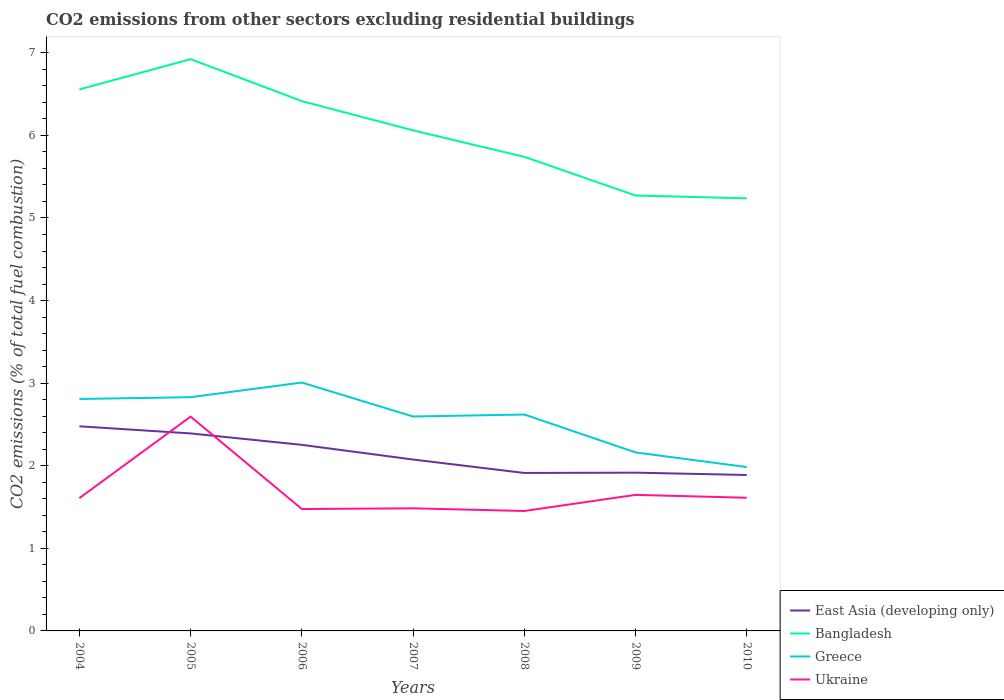Does the line corresponding to Greece intersect with the line corresponding to Bangladesh?
Offer a terse response. No. Is the number of lines equal to the number of legend labels?
Make the answer very short. Yes. Across all years, what is the maximum total CO2 emitted in Greece?
Make the answer very short. 1.98. In which year was the total CO2 emitted in East Asia (developing only) maximum?
Your response must be concise. 2010. What is the total total CO2 emitted in Greece in the graph?
Your response must be concise. 0.21. What is the difference between the highest and the second highest total CO2 emitted in Ukraine?
Keep it short and to the point. 1.14. What is the difference between the highest and the lowest total CO2 emitted in East Asia (developing only)?
Provide a short and direct response. 3. Is the total CO2 emitted in Bangladesh strictly greater than the total CO2 emitted in Ukraine over the years?
Ensure brevity in your answer.  No. How many years are there in the graph?
Ensure brevity in your answer.  7. Are the values on the major ticks of Y-axis written in scientific E-notation?
Offer a very short reply. No. Where does the legend appear in the graph?
Provide a succinct answer. Bottom right. How many legend labels are there?
Ensure brevity in your answer.  4. What is the title of the graph?
Keep it short and to the point. CO2 emissions from other sectors excluding residential buildings. What is the label or title of the X-axis?
Make the answer very short. Years. What is the label or title of the Y-axis?
Offer a very short reply. CO2 emissions (% of total fuel combustion). What is the CO2 emissions (% of total fuel combustion) in East Asia (developing only) in 2004?
Offer a terse response. 2.48. What is the CO2 emissions (% of total fuel combustion) in Bangladesh in 2004?
Give a very brief answer. 6.56. What is the CO2 emissions (% of total fuel combustion) of Greece in 2004?
Keep it short and to the point. 2.81. What is the CO2 emissions (% of total fuel combustion) of Ukraine in 2004?
Your response must be concise. 1.61. What is the CO2 emissions (% of total fuel combustion) in East Asia (developing only) in 2005?
Give a very brief answer. 2.39. What is the CO2 emissions (% of total fuel combustion) of Bangladesh in 2005?
Give a very brief answer. 6.92. What is the CO2 emissions (% of total fuel combustion) in Greece in 2005?
Offer a terse response. 2.83. What is the CO2 emissions (% of total fuel combustion) of Ukraine in 2005?
Offer a very short reply. 2.59. What is the CO2 emissions (% of total fuel combustion) in East Asia (developing only) in 2006?
Offer a terse response. 2.25. What is the CO2 emissions (% of total fuel combustion) in Bangladesh in 2006?
Your answer should be compact. 6.42. What is the CO2 emissions (% of total fuel combustion) in Greece in 2006?
Give a very brief answer. 3.01. What is the CO2 emissions (% of total fuel combustion) of Ukraine in 2006?
Your answer should be very brief. 1.48. What is the CO2 emissions (% of total fuel combustion) in East Asia (developing only) in 2007?
Your answer should be very brief. 2.08. What is the CO2 emissions (% of total fuel combustion) in Bangladesh in 2007?
Your answer should be compact. 6.06. What is the CO2 emissions (% of total fuel combustion) of Greece in 2007?
Your answer should be very brief. 2.6. What is the CO2 emissions (% of total fuel combustion) of Ukraine in 2007?
Make the answer very short. 1.48. What is the CO2 emissions (% of total fuel combustion) of East Asia (developing only) in 2008?
Keep it short and to the point. 1.91. What is the CO2 emissions (% of total fuel combustion) of Bangladesh in 2008?
Ensure brevity in your answer.  5.74. What is the CO2 emissions (% of total fuel combustion) in Greece in 2008?
Offer a very short reply. 2.62. What is the CO2 emissions (% of total fuel combustion) in Ukraine in 2008?
Your response must be concise. 1.45. What is the CO2 emissions (% of total fuel combustion) of East Asia (developing only) in 2009?
Give a very brief answer. 1.92. What is the CO2 emissions (% of total fuel combustion) of Bangladesh in 2009?
Your answer should be compact. 5.27. What is the CO2 emissions (% of total fuel combustion) in Greece in 2009?
Offer a terse response. 2.16. What is the CO2 emissions (% of total fuel combustion) in Ukraine in 2009?
Give a very brief answer. 1.65. What is the CO2 emissions (% of total fuel combustion) of East Asia (developing only) in 2010?
Offer a very short reply. 1.89. What is the CO2 emissions (% of total fuel combustion) in Bangladesh in 2010?
Your response must be concise. 5.24. What is the CO2 emissions (% of total fuel combustion) in Greece in 2010?
Provide a succinct answer. 1.98. What is the CO2 emissions (% of total fuel combustion) of Ukraine in 2010?
Provide a short and direct response. 1.61. Across all years, what is the maximum CO2 emissions (% of total fuel combustion) in East Asia (developing only)?
Offer a very short reply. 2.48. Across all years, what is the maximum CO2 emissions (% of total fuel combustion) in Bangladesh?
Keep it short and to the point. 6.92. Across all years, what is the maximum CO2 emissions (% of total fuel combustion) in Greece?
Your answer should be very brief. 3.01. Across all years, what is the maximum CO2 emissions (% of total fuel combustion) of Ukraine?
Give a very brief answer. 2.59. Across all years, what is the minimum CO2 emissions (% of total fuel combustion) of East Asia (developing only)?
Offer a very short reply. 1.89. Across all years, what is the minimum CO2 emissions (% of total fuel combustion) in Bangladesh?
Provide a short and direct response. 5.24. Across all years, what is the minimum CO2 emissions (% of total fuel combustion) in Greece?
Offer a very short reply. 1.98. Across all years, what is the minimum CO2 emissions (% of total fuel combustion) of Ukraine?
Offer a very short reply. 1.45. What is the total CO2 emissions (% of total fuel combustion) of East Asia (developing only) in the graph?
Ensure brevity in your answer.  14.91. What is the total CO2 emissions (% of total fuel combustion) of Bangladesh in the graph?
Provide a succinct answer. 42.21. What is the total CO2 emissions (% of total fuel combustion) in Greece in the graph?
Your answer should be very brief. 18.01. What is the total CO2 emissions (% of total fuel combustion) of Ukraine in the graph?
Provide a short and direct response. 11.88. What is the difference between the CO2 emissions (% of total fuel combustion) of East Asia (developing only) in 2004 and that in 2005?
Provide a short and direct response. 0.09. What is the difference between the CO2 emissions (% of total fuel combustion) of Bangladesh in 2004 and that in 2005?
Provide a succinct answer. -0.37. What is the difference between the CO2 emissions (% of total fuel combustion) of Greece in 2004 and that in 2005?
Offer a very short reply. -0.02. What is the difference between the CO2 emissions (% of total fuel combustion) of Ukraine in 2004 and that in 2005?
Keep it short and to the point. -0.99. What is the difference between the CO2 emissions (% of total fuel combustion) in East Asia (developing only) in 2004 and that in 2006?
Offer a terse response. 0.22. What is the difference between the CO2 emissions (% of total fuel combustion) of Bangladesh in 2004 and that in 2006?
Offer a terse response. 0.14. What is the difference between the CO2 emissions (% of total fuel combustion) of Greece in 2004 and that in 2006?
Your answer should be compact. -0.2. What is the difference between the CO2 emissions (% of total fuel combustion) in Ukraine in 2004 and that in 2006?
Give a very brief answer. 0.13. What is the difference between the CO2 emissions (% of total fuel combustion) in East Asia (developing only) in 2004 and that in 2007?
Provide a short and direct response. 0.4. What is the difference between the CO2 emissions (% of total fuel combustion) of Bangladesh in 2004 and that in 2007?
Offer a terse response. 0.5. What is the difference between the CO2 emissions (% of total fuel combustion) of Greece in 2004 and that in 2007?
Your answer should be compact. 0.21. What is the difference between the CO2 emissions (% of total fuel combustion) of Ukraine in 2004 and that in 2007?
Keep it short and to the point. 0.12. What is the difference between the CO2 emissions (% of total fuel combustion) of East Asia (developing only) in 2004 and that in 2008?
Offer a very short reply. 0.56. What is the difference between the CO2 emissions (% of total fuel combustion) in Bangladesh in 2004 and that in 2008?
Make the answer very short. 0.82. What is the difference between the CO2 emissions (% of total fuel combustion) in Greece in 2004 and that in 2008?
Offer a very short reply. 0.19. What is the difference between the CO2 emissions (% of total fuel combustion) of Ukraine in 2004 and that in 2008?
Your answer should be very brief. 0.16. What is the difference between the CO2 emissions (% of total fuel combustion) of East Asia (developing only) in 2004 and that in 2009?
Give a very brief answer. 0.56. What is the difference between the CO2 emissions (% of total fuel combustion) in Bangladesh in 2004 and that in 2009?
Your answer should be compact. 1.28. What is the difference between the CO2 emissions (% of total fuel combustion) in Greece in 2004 and that in 2009?
Offer a terse response. 0.65. What is the difference between the CO2 emissions (% of total fuel combustion) of Ukraine in 2004 and that in 2009?
Your answer should be very brief. -0.04. What is the difference between the CO2 emissions (% of total fuel combustion) in East Asia (developing only) in 2004 and that in 2010?
Offer a terse response. 0.59. What is the difference between the CO2 emissions (% of total fuel combustion) of Bangladesh in 2004 and that in 2010?
Your answer should be compact. 1.32. What is the difference between the CO2 emissions (% of total fuel combustion) in Greece in 2004 and that in 2010?
Keep it short and to the point. 0.82. What is the difference between the CO2 emissions (% of total fuel combustion) in Ukraine in 2004 and that in 2010?
Ensure brevity in your answer.  -0. What is the difference between the CO2 emissions (% of total fuel combustion) in East Asia (developing only) in 2005 and that in 2006?
Provide a succinct answer. 0.14. What is the difference between the CO2 emissions (% of total fuel combustion) of Bangladesh in 2005 and that in 2006?
Provide a short and direct response. 0.51. What is the difference between the CO2 emissions (% of total fuel combustion) of Greece in 2005 and that in 2006?
Your answer should be compact. -0.18. What is the difference between the CO2 emissions (% of total fuel combustion) of Ukraine in 2005 and that in 2006?
Your response must be concise. 1.12. What is the difference between the CO2 emissions (% of total fuel combustion) of East Asia (developing only) in 2005 and that in 2007?
Ensure brevity in your answer.  0.32. What is the difference between the CO2 emissions (% of total fuel combustion) in Bangladesh in 2005 and that in 2007?
Provide a succinct answer. 0.86. What is the difference between the CO2 emissions (% of total fuel combustion) in Greece in 2005 and that in 2007?
Offer a very short reply. 0.23. What is the difference between the CO2 emissions (% of total fuel combustion) in Ukraine in 2005 and that in 2007?
Make the answer very short. 1.11. What is the difference between the CO2 emissions (% of total fuel combustion) in East Asia (developing only) in 2005 and that in 2008?
Give a very brief answer. 0.48. What is the difference between the CO2 emissions (% of total fuel combustion) of Bangladesh in 2005 and that in 2008?
Provide a short and direct response. 1.18. What is the difference between the CO2 emissions (% of total fuel combustion) of Greece in 2005 and that in 2008?
Your answer should be compact. 0.21. What is the difference between the CO2 emissions (% of total fuel combustion) of Ukraine in 2005 and that in 2008?
Keep it short and to the point. 1.14. What is the difference between the CO2 emissions (% of total fuel combustion) of East Asia (developing only) in 2005 and that in 2009?
Provide a short and direct response. 0.48. What is the difference between the CO2 emissions (% of total fuel combustion) in Bangladesh in 2005 and that in 2009?
Offer a very short reply. 1.65. What is the difference between the CO2 emissions (% of total fuel combustion) in Greece in 2005 and that in 2009?
Your answer should be very brief. 0.67. What is the difference between the CO2 emissions (% of total fuel combustion) of Ukraine in 2005 and that in 2009?
Keep it short and to the point. 0.95. What is the difference between the CO2 emissions (% of total fuel combustion) of East Asia (developing only) in 2005 and that in 2010?
Give a very brief answer. 0.5. What is the difference between the CO2 emissions (% of total fuel combustion) of Bangladesh in 2005 and that in 2010?
Give a very brief answer. 1.69. What is the difference between the CO2 emissions (% of total fuel combustion) of Greece in 2005 and that in 2010?
Ensure brevity in your answer.  0.85. What is the difference between the CO2 emissions (% of total fuel combustion) in Ukraine in 2005 and that in 2010?
Keep it short and to the point. 0.98. What is the difference between the CO2 emissions (% of total fuel combustion) in East Asia (developing only) in 2006 and that in 2007?
Give a very brief answer. 0.18. What is the difference between the CO2 emissions (% of total fuel combustion) of Bangladesh in 2006 and that in 2007?
Your response must be concise. 0.35. What is the difference between the CO2 emissions (% of total fuel combustion) of Greece in 2006 and that in 2007?
Give a very brief answer. 0.41. What is the difference between the CO2 emissions (% of total fuel combustion) of Ukraine in 2006 and that in 2007?
Offer a terse response. -0.01. What is the difference between the CO2 emissions (% of total fuel combustion) of East Asia (developing only) in 2006 and that in 2008?
Your answer should be compact. 0.34. What is the difference between the CO2 emissions (% of total fuel combustion) in Bangladesh in 2006 and that in 2008?
Offer a very short reply. 0.67. What is the difference between the CO2 emissions (% of total fuel combustion) in Greece in 2006 and that in 2008?
Your response must be concise. 0.39. What is the difference between the CO2 emissions (% of total fuel combustion) of Ukraine in 2006 and that in 2008?
Your response must be concise. 0.02. What is the difference between the CO2 emissions (% of total fuel combustion) in East Asia (developing only) in 2006 and that in 2009?
Make the answer very short. 0.34. What is the difference between the CO2 emissions (% of total fuel combustion) of Bangladesh in 2006 and that in 2009?
Offer a terse response. 1.14. What is the difference between the CO2 emissions (% of total fuel combustion) of Greece in 2006 and that in 2009?
Your answer should be compact. 0.85. What is the difference between the CO2 emissions (% of total fuel combustion) in Ukraine in 2006 and that in 2009?
Offer a very short reply. -0.17. What is the difference between the CO2 emissions (% of total fuel combustion) in East Asia (developing only) in 2006 and that in 2010?
Your answer should be compact. 0.36. What is the difference between the CO2 emissions (% of total fuel combustion) in Bangladesh in 2006 and that in 2010?
Ensure brevity in your answer.  1.18. What is the difference between the CO2 emissions (% of total fuel combustion) in Greece in 2006 and that in 2010?
Keep it short and to the point. 1.02. What is the difference between the CO2 emissions (% of total fuel combustion) of Ukraine in 2006 and that in 2010?
Give a very brief answer. -0.14. What is the difference between the CO2 emissions (% of total fuel combustion) of East Asia (developing only) in 2007 and that in 2008?
Provide a succinct answer. 0.16. What is the difference between the CO2 emissions (% of total fuel combustion) of Bangladesh in 2007 and that in 2008?
Give a very brief answer. 0.32. What is the difference between the CO2 emissions (% of total fuel combustion) in Greece in 2007 and that in 2008?
Provide a succinct answer. -0.02. What is the difference between the CO2 emissions (% of total fuel combustion) of Ukraine in 2007 and that in 2008?
Your response must be concise. 0.03. What is the difference between the CO2 emissions (% of total fuel combustion) in East Asia (developing only) in 2007 and that in 2009?
Provide a short and direct response. 0.16. What is the difference between the CO2 emissions (% of total fuel combustion) of Bangladesh in 2007 and that in 2009?
Provide a short and direct response. 0.79. What is the difference between the CO2 emissions (% of total fuel combustion) of Greece in 2007 and that in 2009?
Your answer should be very brief. 0.43. What is the difference between the CO2 emissions (% of total fuel combustion) of Ukraine in 2007 and that in 2009?
Your response must be concise. -0.16. What is the difference between the CO2 emissions (% of total fuel combustion) of East Asia (developing only) in 2007 and that in 2010?
Make the answer very short. 0.19. What is the difference between the CO2 emissions (% of total fuel combustion) in Bangladesh in 2007 and that in 2010?
Ensure brevity in your answer.  0.82. What is the difference between the CO2 emissions (% of total fuel combustion) in Greece in 2007 and that in 2010?
Your answer should be very brief. 0.61. What is the difference between the CO2 emissions (% of total fuel combustion) of Ukraine in 2007 and that in 2010?
Ensure brevity in your answer.  -0.13. What is the difference between the CO2 emissions (% of total fuel combustion) in East Asia (developing only) in 2008 and that in 2009?
Your answer should be very brief. -0. What is the difference between the CO2 emissions (% of total fuel combustion) in Bangladesh in 2008 and that in 2009?
Give a very brief answer. 0.47. What is the difference between the CO2 emissions (% of total fuel combustion) in Greece in 2008 and that in 2009?
Give a very brief answer. 0.46. What is the difference between the CO2 emissions (% of total fuel combustion) in Ukraine in 2008 and that in 2009?
Offer a terse response. -0.2. What is the difference between the CO2 emissions (% of total fuel combustion) in East Asia (developing only) in 2008 and that in 2010?
Your response must be concise. 0.02. What is the difference between the CO2 emissions (% of total fuel combustion) in Bangladesh in 2008 and that in 2010?
Ensure brevity in your answer.  0.5. What is the difference between the CO2 emissions (% of total fuel combustion) in Greece in 2008 and that in 2010?
Your answer should be very brief. 0.64. What is the difference between the CO2 emissions (% of total fuel combustion) in Ukraine in 2008 and that in 2010?
Provide a short and direct response. -0.16. What is the difference between the CO2 emissions (% of total fuel combustion) in East Asia (developing only) in 2009 and that in 2010?
Provide a succinct answer. 0.03. What is the difference between the CO2 emissions (% of total fuel combustion) of Bangladesh in 2009 and that in 2010?
Your answer should be very brief. 0.03. What is the difference between the CO2 emissions (% of total fuel combustion) of Greece in 2009 and that in 2010?
Ensure brevity in your answer.  0.18. What is the difference between the CO2 emissions (% of total fuel combustion) of Ukraine in 2009 and that in 2010?
Keep it short and to the point. 0.04. What is the difference between the CO2 emissions (% of total fuel combustion) in East Asia (developing only) in 2004 and the CO2 emissions (% of total fuel combustion) in Bangladesh in 2005?
Provide a succinct answer. -4.45. What is the difference between the CO2 emissions (% of total fuel combustion) in East Asia (developing only) in 2004 and the CO2 emissions (% of total fuel combustion) in Greece in 2005?
Your answer should be very brief. -0.35. What is the difference between the CO2 emissions (% of total fuel combustion) in East Asia (developing only) in 2004 and the CO2 emissions (% of total fuel combustion) in Ukraine in 2005?
Your response must be concise. -0.12. What is the difference between the CO2 emissions (% of total fuel combustion) in Bangladesh in 2004 and the CO2 emissions (% of total fuel combustion) in Greece in 2005?
Ensure brevity in your answer.  3.73. What is the difference between the CO2 emissions (% of total fuel combustion) of Bangladesh in 2004 and the CO2 emissions (% of total fuel combustion) of Ukraine in 2005?
Give a very brief answer. 3.96. What is the difference between the CO2 emissions (% of total fuel combustion) of Greece in 2004 and the CO2 emissions (% of total fuel combustion) of Ukraine in 2005?
Your answer should be compact. 0.21. What is the difference between the CO2 emissions (% of total fuel combustion) of East Asia (developing only) in 2004 and the CO2 emissions (% of total fuel combustion) of Bangladesh in 2006?
Provide a succinct answer. -3.94. What is the difference between the CO2 emissions (% of total fuel combustion) of East Asia (developing only) in 2004 and the CO2 emissions (% of total fuel combustion) of Greece in 2006?
Give a very brief answer. -0.53. What is the difference between the CO2 emissions (% of total fuel combustion) in Bangladesh in 2004 and the CO2 emissions (% of total fuel combustion) in Greece in 2006?
Your answer should be very brief. 3.55. What is the difference between the CO2 emissions (% of total fuel combustion) in Bangladesh in 2004 and the CO2 emissions (% of total fuel combustion) in Ukraine in 2006?
Your response must be concise. 5.08. What is the difference between the CO2 emissions (% of total fuel combustion) in Greece in 2004 and the CO2 emissions (% of total fuel combustion) in Ukraine in 2006?
Keep it short and to the point. 1.33. What is the difference between the CO2 emissions (% of total fuel combustion) of East Asia (developing only) in 2004 and the CO2 emissions (% of total fuel combustion) of Bangladesh in 2007?
Give a very brief answer. -3.58. What is the difference between the CO2 emissions (% of total fuel combustion) of East Asia (developing only) in 2004 and the CO2 emissions (% of total fuel combustion) of Greece in 2007?
Give a very brief answer. -0.12. What is the difference between the CO2 emissions (% of total fuel combustion) of Bangladesh in 2004 and the CO2 emissions (% of total fuel combustion) of Greece in 2007?
Offer a terse response. 3.96. What is the difference between the CO2 emissions (% of total fuel combustion) of Bangladesh in 2004 and the CO2 emissions (% of total fuel combustion) of Ukraine in 2007?
Give a very brief answer. 5.07. What is the difference between the CO2 emissions (% of total fuel combustion) in Greece in 2004 and the CO2 emissions (% of total fuel combustion) in Ukraine in 2007?
Give a very brief answer. 1.32. What is the difference between the CO2 emissions (% of total fuel combustion) in East Asia (developing only) in 2004 and the CO2 emissions (% of total fuel combustion) in Bangladesh in 2008?
Ensure brevity in your answer.  -3.26. What is the difference between the CO2 emissions (% of total fuel combustion) of East Asia (developing only) in 2004 and the CO2 emissions (% of total fuel combustion) of Greece in 2008?
Offer a terse response. -0.14. What is the difference between the CO2 emissions (% of total fuel combustion) of East Asia (developing only) in 2004 and the CO2 emissions (% of total fuel combustion) of Ukraine in 2008?
Ensure brevity in your answer.  1.03. What is the difference between the CO2 emissions (% of total fuel combustion) of Bangladesh in 2004 and the CO2 emissions (% of total fuel combustion) of Greece in 2008?
Your response must be concise. 3.94. What is the difference between the CO2 emissions (% of total fuel combustion) in Bangladesh in 2004 and the CO2 emissions (% of total fuel combustion) in Ukraine in 2008?
Provide a succinct answer. 5.1. What is the difference between the CO2 emissions (% of total fuel combustion) in Greece in 2004 and the CO2 emissions (% of total fuel combustion) in Ukraine in 2008?
Offer a terse response. 1.36. What is the difference between the CO2 emissions (% of total fuel combustion) of East Asia (developing only) in 2004 and the CO2 emissions (% of total fuel combustion) of Bangladesh in 2009?
Offer a terse response. -2.79. What is the difference between the CO2 emissions (% of total fuel combustion) of East Asia (developing only) in 2004 and the CO2 emissions (% of total fuel combustion) of Greece in 2009?
Keep it short and to the point. 0.32. What is the difference between the CO2 emissions (% of total fuel combustion) in East Asia (developing only) in 2004 and the CO2 emissions (% of total fuel combustion) in Ukraine in 2009?
Your answer should be very brief. 0.83. What is the difference between the CO2 emissions (% of total fuel combustion) in Bangladesh in 2004 and the CO2 emissions (% of total fuel combustion) in Greece in 2009?
Give a very brief answer. 4.4. What is the difference between the CO2 emissions (% of total fuel combustion) of Bangladesh in 2004 and the CO2 emissions (% of total fuel combustion) of Ukraine in 2009?
Ensure brevity in your answer.  4.91. What is the difference between the CO2 emissions (% of total fuel combustion) in Greece in 2004 and the CO2 emissions (% of total fuel combustion) in Ukraine in 2009?
Your answer should be compact. 1.16. What is the difference between the CO2 emissions (% of total fuel combustion) in East Asia (developing only) in 2004 and the CO2 emissions (% of total fuel combustion) in Bangladesh in 2010?
Your response must be concise. -2.76. What is the difference between the CO2 emissions (% of total fuel combustion) of East Asia (developing only) in 2004 and the CO2 emissions (% of total fuel combustion) of Greece in 2010?
Keep it short and to the point. 0.49. What is the difference between the CO2 emissions (% of total fuel combustion) in East Asia (developing only) in 2004 and the CO2 emissions (% of total fuel combustion) in Ukraine in 2010?
Keep it short and to the point. 0.87. What is the difference between the CO2 emissions (% of total fuel combustion) in Bangladesh in 2004 and the CO2 emissions (% of total fuel combustion) in Greece in 2010?
Provide a succinct answer. 4.57. What is the difference between the CO2 emissions (% of total fuel combustion) in Bangladesh in 2004 and the CO2 emissions (% of total fuel combustion) in Ukraine in 2010?
Keep it short and to the point. 4.94. What is the difference between the CO2 emissions (% of total fuel combustion) of Greece in 2004 and the CO2 emissions (% of total fuel combustion) of Ukraine in 2010?
Give a very brief answer. 1.2. What is the difference between the CO2 emissions (% of total fuel combustion) in East Asia (developing only) in 2005 and the CO2 emissions (% of total fuel combustion) in Bangladesh in 2006?
Provide a succinct answer. -4.02. What is the difference between the CO2 emissions (% of total fuel combustion) of East Asia (developing only) in 2005 and the CO2 emissions (% of total fuel combustion) of Greece in 2006?
Provide a succinct answer. -0.62. What is the difference between the CO2 emissions (% of total fuel combustion) in East Asia (developing only) in 2005 and the CO2 emissions (% of total fuel combustion) in Ukraine in 2006?
Ensure brevity in your answer.  0.92. What is the difference between the CO2 emissions (% of total fuel combustion) in Bangladesh in 2005 and the CO2 emissions (% of total fuel combustion) in Greece in 2006?
Provide a short and direct response. 3.92. What is the difference between the CO2 emissions (% of total fuel combustion) of Bangladesh in 2005 and the CO2 emissions (% of total fuel combustion) of Ukraine in 2006?
Give a very brief answer. 5.45. What is the difference between the CO2 emissions (% of total fuel combustion) in Greece in 2005 and the CO2 emissions (% of total fuel combustion) in Ukraine in 2006?
Your answer should be compact. 1.35. What is the difference between the CO2 emissions (% of total fuel combustion) in East Asia (developing only) in 2005 and the CO2 emissions (% of total fuel combustion) in Bangladesh in 2007?
Your response must be concise. -3.67. What is the difference between the CO2 emissions (% of total fuel combustion) in East Asia (developing only) in 2005 and the CO2 emissions (% of total fuel combustion) in Greece in 2007?
Ensure brevity in your answer.  -0.2. What is the difference between the CO2 emissions (% of total fuel combustion) of East Asia (developing only) in 2005 and the CO2 emissions (% of total fuel combustion) of Ukraine in 2007?
Ensure brevity in your answer.  0.91. What is the difference between the CO2 emissions (% of total fuel combustion) in Bangladesh in 2005 and the CO2 emissions (% of total fuel combustion) in Greece in 2007?
Make the answer very short. 4.33. What is the difference between the CO2 emissions (% of total fuel combustion) of Bangladesh in 2005 and the CO2 emissions (% of total fuel combustion) of Ukraine in 2007?
Give a very brief answer. 5.44. What is the difference between the CO2 emissions (% of total fuel combustion) in Greece in 2005 and the CO2 emissions (% of total fuel combustion) in Ukraine in 2007?
Your answer should be compact. 1.35. What is the difference between the CO2 emissions (% of total fuel combustion) in East Asia (developing only) in 2005 and the CO2 emissions (% of total fuel combustion) in Bangladesh in 2008?
Ensure brevity in your answer.  -3.35. What is the difference between the CO2 emissions (% of total fuel combustion) of East Asia (developing only) in 2005 and the CO2 emissions (% of total fuel combustion) of Greece in 2008?
Your answer should be compact. -0.23. What is the difference between the CO2 emissions (% of total fuel combustion) in East Asia (developing only) in 2005 and the CO2 emissions (% of total fuel combustion) in Ukraine in 2008?
Give a very brief answer. 0.94. What is the difference between the CO2 emissions (% of total fuel combustion) in Bangladesh in 2005 and the CO2 emissions (% of total fuel combustion) in Greece in 2008?
Offer a very short reply. 4.3. What is the difference between the CO2 emissions (% of total fuel combustion) in Bangladesh in 2005 and the CO2 emissions (% of total fuel combustion) in Ukraine in 2008?
Your answer should be very brief. 5.47. What is the difference between the CO2 emissions (% of total fuel combustion) of Greece in 2005 and the CO2 emissions (% of total fuel combustion) of Ukraine in 2008?
Your answer should be very brief. 1.38. What is the difference between the CO2 emissions (% of total fuel combustion) in East Asia (developing only) in 2005 and the CO2 emissions (% of total fuel combustion) in Bangladesh in 2009?
Ensure brevity in your answer.  -2.88. What is the difference between the CO2 emissions (% of total fuel combustion) in East Asia (developing only) in 2005 and the CO2 emissions (% of total fuel combustion) in Greece in 2009?
Ensure brevity in your answer.  0.23. What is the difference between the CO2 emissions (% of total fuel combustion) of East Asia (developing only) in 2005 and the CO2 emissions (% of total fuel combustion) of Ukraine in 2009?
Keep it short and to the point. 0.74. What is the difference between the CO2 emissions (% of total fuel combustion) in Bangladesh in 2005 and the CO2 emissions (% of total fuel combustion) in Greece in 2009?
Offer a very short reply. 4.76. What is the difference between the CO2 emissions (% of total fuel combustion) in Bangladesh in 2005 and the CO2 emissions (% of total fuel combustion) in Ukraine in 2009?
Give a very brief answer. 5.28. What is the difference between the CO2 emissions (% of total fuel combustion) of Greece in 2005 and the CO2 emissions (% of total fuel combustion) of Ukraine in 2009?
Give a very brief answer. 1.18. What is the difference between the CO2 emissions (% of total fuel combustion) in East Asia (developing only) in 2005 and the CO2 emissions (% of total fuel combustion) in Bangladesh in 2010?
Your answer should be compact. -2.85. What is the difference between the CO2 emissions (% of total fuel combustion) of East Asia (developing only) in 2005 and the CO2 emissions (% of total fuel combustion) of Greece in 2010?
Ensure brevity in your answer.  0.41. What is the difference between the CO2 emissions (% of total fuel combustion) of East Asia (developing only) in 2005 and the CO2 emissions (% of total fuel combustion) of Ukraine in 2010?
Your answer should be very brief. 0.78. What is the difference between the CO2 emissions (% of total fuel combustion) in Bangladesh in 2005 and the CO2 emissions (% of total fuel combustion) in Greece in 2010?
Offer a very short reply. 4.94. What is the difference between the CO2 emissions (% of total fuel combustion) in Bangladesh in 2005 and the CO2 emissions (% of total fuel combustion) in Ukraine in 2010?
Keep it short and to the point. 5.31. What is the difference between the CO2 emissions (% of total fuel combustion) of Greece in 2005 and the CO2 emissions (% of total fuel combustion) of Ukraine in 2010?
Offer a very short reply. 1.22. What is the difference between the CO2 emissions (% of total fuel combustion) of East Asia (developing only) in 2006 and the CO2 emissions (% of total fuel combustion) of Bangladesh in 2007?
Your answer should be very brief. -3.81. What is the difference between the CO2 emissions (% of total fuel combustion) in East Asia (developing only) in 2006 and the CO2 emissions (% of total fuel combustion) in Greece in 2007?
Offer a very short reply. -0.34. What is the difference between the CO2 emissions (% of total fuel combustion) in East Asia (developing only) in 2006 and the CO2 emissions (% of total fuel combustion) in Ukraine in 2007?
Give a very brief answer. 0.77. What is the difference between the CO2 emissions (% of total fuel combustion) of Bangladesh in 2006 and the CO2 emissions (% of total fuel combustion) of Greece in 2007?
Offer a very short reply. 3.82. What is the difference between the CO2 emissions (% of total fuel combustion) of Bangladesh in 2006 and the CO2 emissions (% of total fuel combustion) of Ukraine in 2007?
Your response must be concise. 4.93. What is the difference between the CO2 emissions (% of total fuel combustion) in Greece in 2006 and the CO2 emissions (% of total fuel combustion) in Ukraine in 2007?
Your response must be concise. 1.52. What is the difference between the CO2 emissions (% of total fuel combustion) in East Asia (developing only) in 2006 and the CO2 emissions (% of total fuel combustion) in Bangladesh in 2008?
Keep it short and to the point. -3.49. What is the difference between the CO2 emissions (% of total fuel combustion) of East Asia (developing only) in 2006 and the CO2 emissions (% of total fuel combustion) of Greece in 2008?
Offer a terse response. -0.37. What is the difference between the CO2 emissions (% of total fuel combustion) of East Asia (developing only) in 2006 and the CO2 emissions (% of total fuel combustion) of Ukraine in 2008?
Ensure brevity in your answer.  0.8. What is the difference between the CO2 emissions (% of total fuel combustion) of Bangladesh in 2006 and the CO2 emissions (% of total fuel combustion) of Greece in 2008?
Your answer should be very brief. 3.79. What is the difference between the CO2 emissions (% of total fuel combustion) in Bangladesh in 2006 and the CO2 emissions (% of total fuel combustion) in Ukraine in 2008?
Offer a very short reply. 4.96. What is the difference between the CO2 emissions (% of total fuel combustion) of Greece in 2006 and the CO2 emissions (% of total fuel combustion) of Ukraine in 2008?
Your response must be concise. 1.56. What is the difference between the CO2 emissions (% of total fuel combustion) in East Asia (developing only) in 2006 and the CO2 emissions (% of total fuel combustion) in Bangladesh in 2009?
Make the answer very short. -3.02. What is the difference between the CO2 emissions (% of total fuel combustion) in East Asia (developing only) in 2006 and the CO2 emissions (% of total fuel combustion) in Greece in 2009?
Ensure brevity in your answer.  0.09. What is the difference between the CO2 emissions (% of total fuel combustion) in East Asia (developing only) in 2006 and the CO2 emissions (% of total fuel combustion) in Ukraine in 2009?
Keep it short and to the point. 0.61. What is the difference between the CO2 emissions (% of total fuel combustion) in Bangladesh in 2006 and the CO2 emissions (% of total fuel combustion) in Greece in 2009?
Give a very brief answer. 4.25. What is the difference between the CO2 emissions (% of total fuel combustion) of Bangladesh in 2006 and the CO2 emissions (% of total fuel combustion) of Ukraine in 2009?
Offer a terse response. 4.77. What is the difference between the CO2 emissions (% of total fuel combustion) of Greece in 2006 and the CO2 emissions (% of total fuel combustion) of Ukraine in 2009?
Ensure brevity in your answer.  1.36. What is the difference between the CO2 emissions (% of total fuel combustion) of East Asia (developing only) in 2006 and the CO2 emissions (% of total fuel combustion) of Bangladesh in 2010?
Your answer should be compact. -2.99. What is the difference between the CO2 emissions (% of total fuel combustion) of East Asia (developing only) in 2006 and the CO2 emissions (% of total fuel combustion) of Greece in 2010?
Your answer should be compact. 0.27. What is the difference between the CO2 emissions (% of total fuel combustion) of East Asia (developing only) in 2006 and the CO2 emissions (% of total fuel combustion) of Ukraine in 2010?
Make the answer very short. 0.64. What is the difference between the CO2 emissions (% of total fuel combustion) in Bangladesh in 2006 and the CO2 emissions (% of total fuel combustion) in Greece in 2010?
Keep it short and to the point. 4.43. What is the difference between the CO2 emissions (% of total fuel combustion) of Bangladesh in 2006 and the CO2 emissions (% of total fuel combustion) of Ukraine in 2010?
Provide a short and direct response. 4.8. What is the difference between the CO2 emissions (% of total fuel combustion) of Greece in 2006 and the CO2 emissions (% of total fuel combustion) of Ukraine in 2010?
Your response must be concise. 1.4. What is the difference between the CO2 emissions (% of total fuel combustion) in East Asia (developing only) in 2007 and the CO2 emissions (% of total fuel combustion) in Bangladesh in 2008?
Offer a terse response. -3.67. What is the difference between the CO2 emissions (% of total fuel combustion) of East Asia (developing only) in 2007 and the CO2 emissions (% of total fuel combustion) of Greece in 2008?
Provide a short and direct response. -0.55. What is the difference between the CO2 emissions (% of total fuel combustion) of East Asia (developing only) in 2007 and the CO2 emissions (% of total fuel combustion) of Ukraine in 2008?
Offer a very short reply. 0.62. What is the difference between the CO2 emissions (% of total fuel combustion) of Bangladesh in 2007 and the CO2 emissions (% of total fuel combustion) of Greece in 2008?
Your response must be concise. 3.44. What is the difference between the CO2 emissions (% of total fuel combustion) in Bangladesh in 2007 and the CO2 emissions (% of total fuel combustion) in Ukraine in 2008?
Offer a terse response. 4.61. What is the difference between the CO2 emissions (% of total fuel combustion) of Greece in 2007 and the CO2 emissions (% of total fuel combustion) of Ukraine in 2008?
Keep it short and to the point. 1.14. What is the difference between the CO2 emissions (% of total fuel combustion) of East Asia (developing only) in 2007 and the CO2 emissions (% of total fuel combustion) of Bangladesh in 2009?
Offer a terse response. -3.2. What is the difference between the CO2 emissions (% of total fuel combustion) in East Asia (developing only) in 2007 and the CO2 emissions (% of total fuel combustion) in Greece in 2009?
Provide a succinct answer. -0.09. What is the difference between the CO2 emissions (% of total fuel combustion) in East Asia (developing only) in 2007 and the CO2 emissions (% of total fuel combustion) in Ukraine in 2009?
Keep it short and to the point. 0.43. What is the difference between the CO2 emissions (% of total fuel combustion) of Bangladesh in 2007 and the CO2 emissions (% of total fuel combustion) of Greece in 2009?
Provide a short and direct response. 3.9. What is the difference between the CO2 emissions (% of total fuel combustion) of Bangladesh in 2007 and the CO2 emissions (% of total fuel combustion) of Ukraine in 2009?
Your answer should be compact. 4.41. What is the difference between the CO2 emissions (% of total fuel combustion) in Greece in 2007 and the CO2 emissions (% of total fuel combustion) in Ukraine in 2009?
Provide a succinct answer. 0.95. What is the difference between the CO2 emissions (% of total fuel combustion) of East Asia (developing only) in 2007 and the CO2 emissions (% of total fuel combustion) of Bangladesh in 2010?
Provide a succinct answer. -3.16. What is the difference between the CO2 emissions (% of total fuel combustion) of East Asia (developing only) in 2007 and the CO2 emissions (% of total fuel combustion) of Greece in 2010?
Provide a succinct answer. 0.09. What is the difference between the CO2 emissions (% of total fuel combustion) in East Asia (developing only) in 2007 and the CO2 emissions (% of total fuel combustion) in Ukraine in 2010?
Provide a succinct answer. 0.46. What is the difference between the CO2 emissions (% of total fuel combustion) of Bangladesh in 2007 and the CO2 emissions (% of total fuel combustion) of Greece in 2010?
Give a very brief answer. 4.08. What is the difference between the CO2 emissions (% of total fuel combustion) in Bangladesh in 2007 and the CO2 emissions (% of total fuel combustion) in Ukraine in 2010?
Provide a succinct answer. 4.45. What is the difference between the CO2 emissions (% of total fuel combustion) in Greece in 2007 and the CO2 emissions (% of total fuel combustion) in Ukraine in 2010?
Ensure brevity in your answer.  0.98. What is the difference between the CO2 emissions (% of total fuel combustion) in East Asia (developing only) in 2008 and the CO2 emissions (% of total fuel combustion) in Bangladesh in 2009?
Keep it short and to the point. -3.36. What is the difference between the CO2 emissions (% of total fuel combustion) in East Asia (developing only) in 2008 and the CO2 emissions (% of total fuel combustion) in Greece in 2009?
Your answer should be compact. -0.25. What is the difference between the CO2 emissions (% of total fuel combustion) of East Asia (developing only) in 2008 and the CO2 emissions (% of total fuel combustion) of Ukraine in 2009?
Provide a succinct answer. 0.27. What is the difference between the CO2 emissions (% of total fuel combustion) in Bangladesh in 2008 and the CO2 emissions (% of total fuel combustion) in Greece in 2009?
Your answer should be compact. 3.58. What is the difference between the CO2 emissions (% of total fuel combustion) of Bangladesh in 2008 and the CO2 emissions (% of total fuel combustion) of Ukraine in 2009?
Your response must be concise. 4.09. What is the difference between the CO2 emissions (% of total fuel combustion) of Greece in 2008 and the CO2 emissions (% of total fuel combustion) of Ukraine in 2009?
Keep it short and to the point. 0.97. What is the difference between the CO2 emissions (% of total fuel combustion) of East Asia (developing only) in 2008 and the CO2 emissions (% of total fuel combustion) of Bangladesh in 2010?
Provide a short and direct response. -3.33. What is the difference between the CO2 emissions (% of total fuel combustion) in East Asia (developing only) in 2008 and the CO2 emissions (% of total fuel combustion) in Greece in 2010?
Your answer should be compact. -0.07. What is the difference between the CO2 emissions (% of total fuel combustion) of East Asia (developing only) in 2008 and the CO2 emissions (% of total fuel combustion) of Ukraine in 2010?
Your answer should be very brief. 0.3. What is the difference between the CO2 emissions (% of total fuel combustion) in Bangladesh in 2008 and the CO2 emissions (% of total fuel combustion) in Greece in 2010?
Provide a short and direct response. 3.76. What is the difference between the CO2 emissions (% of total fuel combustion) of Bangladesh in 2008 and the CO2 emissions (% of total fuel combustion) of Ukraine in 2010?
Your answer should be very brief. 4.13. What is the difference between the CO2 emissions (% of total fuel combustion) in Greece in 2008 and the CO2 emissions (% of total fuel combustion) in Ukraine in 2010?
Offer a terse response. 1.01. What is the difference between the CO2 emissions (% of total fuel combustion) in East Asia (developing only) in 2009 and the CO2 emissions (% of total fuel combustion) in Bangladesh in 2010?
Provide a succinct answer. -3.32. What is the difference between the CO2 emissions (% of total fuel combustion) in East Asia (developing only) in 2009 and the CO2 emissions (% of total fuel combustion) in Greece in 2010?
Your answer should be compact. -0.07. What is the difference between the CO2 emissions (% of total fuel combustion) in East Asia (developing only) in 2009 and the CO2 emissions (% of total fuel combustion) in Ukraine in 2010?
Make the answer very short. 0.3. What is the difference between the CO2 emissions (% of total fuel combustion) of Bangladesh in 2009 and the CO2 emissions (% of total fuel combustion) of Greece in 2010?
Offer a terse response. 3.29. What is the difference between the CO2 emissions (% of total fuel combustion) of Bangladesh in 2009 and the CO2 emissions (% of total fuel combustion) of Ukraine in 2010?
Give a very brief answer. 3.66. What is the difference between the CO2 emissions (% of total fuel combustion) in Greece in 2009 and the CO2 emissions (% of total fuel combustion) in Ukraine in 2010?
Your answer should be very brief. 0.55. What is the average CO2 emissions (% of total fuel combustion) in East Asia (developing only) per year?
Provide a short and direct response. 2.13. What is the average CO2 emissions (% of total fuel combustion) of Bangladesh per year?
Provide a succinct answer. 6.03. What is the average CO2 emissions (% of total fuel combustion) of Greece per year?
Offer a very short reply. 2.57. What is the average CO2 emissions (% of total fuel combustion) in Ukraine per year?
Offer a very short reply. 1.7. In the year 2004, what is the difference between the CO2 emissions (% of total fuel combustion) in East Asia (developing only) and CO2 emissions (% of total fuel combustion) in Bangladesh?
Make the answer very short. -4.08. In the year 2004, what is the difference between the CO2 emissions (% of total fuel combustion) in East Asia (developing only) and CO2 emissions (% of total fuel combustion) in Greece?
Provide a short and direct response. -0.33. In the year 2004, what is the difference between the CO2 emissions (% of total fuel combustion) in East Asia (developing only) and CO2 emissions (% of total fuel combustion) in Ukraine?
Your answer should be compact. 0.87. In the year 2004, what is the difference between the CO2 emissions (% of total fuel combustion) in Bangladesh and CO2 emissions (% of total fuel combustion) in Greece?
Make the answer very short. 3.75. In the year 2004, what is the difference between the CO2 emissions (% of total fuel combustion) in Bangladesh and CO2 emissions (% of total fuel combustion) in Ukraine?
Make the answer very short. 4.95. In the year 2004, what is the difference between the CO2 emissions (% of total fuel combustion) in Greece and CO2 emissions (% of total fuel combustion) in Ukraine?
Your answer should be compact. 1.2. In the year 2005, what is the difference between the CO2 emissions (% of total fuel combustion) in East Asia (developing only) and CO2 emissions (% of total fuel combustion) in Bangladesh?
Offer a very short reply. -4.53. In the year 2005, what is the difference between the CO2 emissions (% of total fuel combustion) in East Asia (developing only) and CO2 emissions (% of total fuel combustion) in Greece?
Provide a short and direct response. -0.44. In the year 2005, what is the difference between the CO2 emissions (% of total fuel combustion) of East Asia (developing only) and CO2 emissions (% of total fuel combustion) of Ukraine?
Offer a very short reply. -0.2. In the year 2005, what is the difference between the CO2 emissions (% of total fuel combustion) of Bangladesh and CO2 emissions (% of total fuel combustion) of Greece?
Offer a very short reply. 4.09. In the year 2005, what is the difference between the CO2 emissions (% of total fuel combustion) in Bangladesh and CO2 emissions (% of total fuel combustion) in Ukraine?
Offer a terse response. 4.33. In the year 2005, what is the difference between the CO2 emissions (% of total fuel combustion) of Greece and CO2 emissions (% of total fuel combustion) of Ukraine?
Ensure brevity in your answer.  0.24. In the year 2006, what is the difference between the CO2 emissions (% of total fuel combustion) in East Asia (developing only) and CO2 emissions (% of total fuel combustion) in Bangladesh?
Keep it short and to the point. -4.16. In the year 2006, what is the difference between the CO2 emissions (% of total fuel combustion) in East Asia (developing only) and CO2 emissions (% of total fuel combustion) in Greece?
Your answer should be compact. -0.75. In the year 2006, what is the difference between the CO2 emissions (% of total fuel combustion) of East Asia (developing only) and CO2 emissions (% of total fuel combustion) of Ukraine?
Keep it short and to the point. 0.78. In the year 2006, what is the difference between the CO2 emissions (% of total fuel combustion) in Bangladesh and CO2 emissions (% of total fuel combustion) in Greece?
Your answer should be compact. 3.41. In the year 2006, what is the difference between the CO2 emissions (% of total fuel combustion) in Bangladesh and CO2 emissions (% of total fuel combustion) in Ukraine?
Provide a succinct answer. 4.94. In the year 2006, what is the difference between the CO2 emissions (% of total fuel combustion) in Greece and CO2 emissions (% of total fuel combustion) in Ukraine?
Your answer should be compact. 1.53. In the year 2007, what is the difference between the CO2 emissions (% of total fuel combustion) in East Asia (developing only) and CO2 emissions (% of total fuel combustion) in Bangladesh?
Ensure brevity in your answer.  -3.99. In the year 2007, what is the difference between the CO2 emissions (% of total fuel combustion) in East Asia (developing only) and CO2 emissions (% of total fuel combustion) in Greece?
Offer a very short reply. -0.52. In the year 2007, what is the difference between the CO2 emissions (% of total fuel combustion) of East Asia (developing only) and CO2 emissions (% of total fuel combustion) of Ukraine?
Provide a short and direct response. 0.59. In the year 2007, what is the difference between the CO2 emissions (% of total fuel combustion) of Bangladesh and CO2 emissions (% of total fuel combustion) of Greece?
Keep it short and to the point. 3.46. In the year 2007, what is the difference between the CO2 emissions (% of total fuel combustion) of Bangladesh and CO2 emissions (% of total fuel combustion) of Ukraine?
Your answer should be compact. 4.58. In the year 2007, what is the difference between the CO2 emissions (% of total fuel combustion) in Greece and CO2 emissions (% of total fuel combustion) in Ukraine?
Give a very brief answer. 1.11. In the year 2008, what is the difference between the CO2 emissions (% of total fuel combustion) in East Asia (developing only) and CO2 emissions (% of total fuel combustion) in Bangladesh?
Offer a terse response. -3.83. In the year 2008, what is the difference between the CO2 emissions (% of total fuel combustion) in East Asia (developing only) and CO2 emissions (% of total fuel combustion) in Greece?
Offer a very short reply. -0.71. In the year 2008, what is the difference between the CO2 emissions (% of total fuel combustion) in East Asia (developing only) and CO2 emissions (% of total fuel combustion) in Ukraine?
Offer a very short reply. 0.46. In the year 2008, what is the difference between the CO2 emissions (% of total fuel combustion) in Bangladesh and CO2 emissions (% of total fuel combustion) in Greece?
Give a very brief answer. 3.12. In the year 2008, what is the difference between the CO2 emissions (% of total fuel combustion) of Bangladesh and CO2 emissions (% of total fuel combustion) of Ukraine?
Keep it short and to the point. 4.29. In the year 2008, what is the difference between the CO2 emissions (% of total fuel combustion) in Greece and CO2 emissions (% of total fuel combustion) in Ukraine?
Your response must be concise. 1.17. In the year 2009, what is the difference between the CO2 emissions (% of total fuel combustion) of East Asia (developing only) and CO2 emissions (% of total fuel combustion) of Bangladesh?
Your answer should be very brief. -3.36. In the year 2009, what is the difference between the CO2 emissions (% of total fuel combustion) of East Asia (developing only) and CO2 emissions (% of total fuel combustion) of Greece?
Your response must be concise. -0.24. In the year 2009, what is the difference between the CO2 emissions (% of total fuel combustion) in East Asia (developing only) and CO2 emissions (% of total fuel combustion) in Ukraine?
Your answer should be very brief. 0.27. In the year 2009, what is the difference between the CO2 emissions (% of total fuel combustion) of Bangladesh and CO2 emissions (% of total fuel combustion) of Greece?
Make the answer very short. 3.11. In the year 2009, what is the difference between the CO2 emissions (% of total fuel combustion) in Bangladesh and CO2 emissions (% of total fuel combustion) in Ukraine?
Give a very brief answer. 3.62. In the year 2009, what is the difference between the CO2 emissions (% of total fuel combustion) of Greece and CO2 emissions (% of total fuel combustion) of Ukraine?
Make the answer very short. 0.51. In the year 2010, what is the difference between the CO2 emissions (% of total fuel combustion) in East Asia (developing only) and CO2 emissions (% of total fuel combustion) in Bangladesh?
Ensure brevity in your answer.  -3.35. In the year 2010, what is the difference between the CO2 emissions (% of total fuel combustion) of East Asia (developing only) and CO2 emissions (% of total fuel combustion) of Greece?
Your answer should be very brief. -0.1. In the year 2010, what is the difference between the CO2 emissions (% of total fuel combustion) of East Asia (developing only) and CO2 emissions (% of total fuel combustion) of Ukraine?
Provide a short and direct response. 0.28. In the year 2010, what is the difference between the CO2 emissions (% of total fuel combustion) in Bangladesh and CO2 emissions (% of total fuel combustion) in Greece?
Your answer should be very brief. 3.25. In the year 2010, what is the difference between the CO2 emissions (% of total fuel combustion) in Bangladesh and CO2 emissions (% of total fuel combustion) in Ukraine?
Make the answer very short. 3.63. In the year 2010, what is the difference between the CO2 emissions (% of total fuel combustion) in Greece and CO2 emissions (% of total fuel combustion) in Ukraine?
Ensure brevity in your answer.  0.37. What is the ratio of the CO2 emissions (% of total fuel combustion) in East Asia (developing only) in 2004 to that in 2005?
Keep it short and to the point. 1.04. What is the ratio of the CO2 emissions (% of total fuel combustion) in Bangladesh in 2004 to that in 2005?
Make the answer very short. 0.95. What is the ratio of the CO2 emissions (% of total fuel combustion) of Ukraine in 2004 to that in 2005?
Give a very brief answer. 0.62. What is the ratio of the CO2 emissions (% of total fuel combustion) of East Asia (developing only) in 2004 to that in 2006?
Keep it short and to the point. 1.1. What is the ratio of the CO2 emissions (% of total fuel combustion) of Bangladesh in 2004 to that in 2006?
Make the answer very short. 1.02. What is the ratio of the CO2 emissions (% of total fuel combustion) in Greece in 2004 to that in 2006?
Give a very brief answer. 0.93. What is the ratio of the CO2 emissions (% of total fuel combustion) of Ukraine in 2004 to that in 2006?
Offer a very short reply. 1.09. What is the ratio of the CO2 emissions (% of total fuel combustion) in East Asia (developing only) in 2004 to that in 2007?
Your response must be concise. 1.19. What is the ratio of the CO2 emissions (% of total fuel combustion) in Bangladesh in 2004 to that in 2007?
Your answer should be compact. 1.08. What is the ratio of the CO2 emissions (% of total fuel combustion) of Greece in 2004 to that in 2007?
Offer a very short reply. 1.08. What is the ratio of the CO2 emissions (% of total fuel combustion) in Ukraine in 2004 to that in 2007?
Provide a succinct answer. 1.08. What is the ratio of the CO2 emissions (% of total fuel combustion) in East Asia (developing only) in 2004 to that in 2008?
Make the answer very short. 1.3. What is the ratio of the CO2 emissions (% of total fuel combustion) in Bangladesh in 2004 to that in 2008?
Your response must be concise. 1.14. What is the ratio of the CO2 emissions (% of total fuel combustion) in Greece in 2004 to that in 2008?
Your response must be concise. 1.07. What is the ratio of the CO2 emissions (% of total fuel combustion) of Ukraine in 2004 to that in 2008?
Provide a short and direct response. 1.11. What is the ratio of the CO2 emissions (% of total fuel combustion) in East Asia (developing only) in 2004 to that in 2009?
Give a very brief answer. 1.29. What is the ratio of the CO2 emissions (% of total fuel combustion) of Bangladesh in 2004 to that in 2009?
Provide a short and direct response. 1.24. What is the ratio of the CO2 emissions (% of total fuel combustion) in Greece in 2004 to that in 2009?
Offer a very short reply. 1.3. What is the ratio of the CO2 emissions (% of total fuel combustion) in Ukraine in 2004 to that in 2009?
Offer a terse response. 0.98. What is the ratio of the CO2 emissions (% of total fuel combustion) in East Asia (developing only) in 2004 to that in 2010?
Ensure brevity in your answer.  1.31. What is the ratio of the CO2 emissions (% of total fuel combustion) of Bangladesh in 2004 to that in 2010?
Provide a short and direct response. 1.25. What is the ratio of the CO2 emissions (% of total fuel combustion) of Greece in 2004 to that in 2010?
Provide a succinct answer. 1.42. What is the ratio of the CO2 emissions (% of total fuel combustion) in Ukraine in 2004 to that in 2010?
Make the answer very short. 1. What is the ratio of the CO2 emissions (% of total fuel combustion) in East Asia (developing only) in 2005 to that in 2006?
Offer a terse response. 1.06. What is the ratio of the CO2 emissions (% of total fuel combustion) of Bangladesh in 2005 to that in 2006?
Offer a very short reply. 1.08. What is the ratio of the CO2 emissions (% of total fuel combustion) in Greece in 2005 to that in 2006?
Offer a terse response. 0.94. What is the ratio of the CO2 emissions (% of total fuel combustion) of Ukraine in 2005 to that in 2006?
Make the answer very short. 1.76. What is the ratio of the CO2 emissions (% of total fuel combustion) in East Asia (developing only) in 2005 to that in 2007?
Your answer should be very brief. 1.15. What is the ratio of the CO2 emissions (% of total fuel combustion) of Bangladesh in 2005 to that in 2007?
Ensure brevity in your answer.  1.14. What is the ratio of the CO2 emissions (% of total fuel combustion) in Greece in 2005 to that in 2007?
Your answer should be compact. 1.09. What is the ratio of the CO2 emissions (% of total fuel combustion) of Ukraine in 2005 to that in 2007?
Ensure brevity in your answer.  1.75. What is the ratio of the CO2 emissions (% of total fuel combustion) of East Asia (developing only) in 2005 to that in 2008?
Keep it short and to the point. 1.25. What is the ratio of the CO2 emissions (% of total fuel combustion) in Bangladesh in 2005 to that in 2008?
Ensure brevity in your answer.  1.21. What is the ratio of the CO2 emissions (% of total fuel combustion) in Greece in 2005 to that in 2008?
Your answer should be very brief. 1.08. What is the ratio of the CO2 emissions (% of total fuel combustion) of Ukraine in 2005 to that in 2008?
Your response must be concise. 1.79. What is the ratio of the CO2 emissions (% of total fuel combustion) of East Asia (developing only) in 2005 to that in 2009?
Give a very brief answer. 1.25. What is the ratio of the CO2 emissions (% of total fuel combustion) of Bangladesh in 2005 to that in 2009?
Provide a short and direct response. 1.31. What is the ratio of the CO2 emissions (% of total fuel combustion) of Greece in 2005 to that in 2009?
Offer a very short reply. 1.31. What is the ratio of the CO2 emissions (% of total fuel combustion) of Ukraine in 2005 to that in 2009?
Make the answer very short. 1.58. What is the ratio of the CO2 emissions (% of total fuel combustion) in East Asia (developing only) in 2005 to that in 2010?
Your answer should be very brief. 1.27. What is the ratio of the CO2 emissions (% of total fuel combustion) of Bangladesh in 2005 to that in 2010?
Ensure brevity in your answer.  1.32. What is the ratio of the CO2 emissions (% of total fuel combustion) in Greece in 2005 to that in 2010?
Ensure brevity in your answer.  1.43. What is the ratio of the CO2 emissions (% of total fuel combustion) of Ukraine in 2005 to that in 2010?
Give a very brief answer. 1.61. What is the ratio of the CO2 emissions (% of total fuel combustion) in East Asia (developing only) in 2006 to that in 2007?
Keep it short and to the point. 1.09. What is the ratio of the CO2 emissions (% of total fuel combustion) of Bangladesh in 2006 to that in 2007?
Give a very brief answer. 1.06. What is the ratio of the CO2 emissions (% of total fuel combustion) of Greece in 2006 to that in 2007?
Give a very brief answer. 1.16. What is the ratio of the CO2 emissions (% of total fuel combustion) in East Asia (developing only) in 2006 to that in 2008?
Your answer should be compact. 1.18. What is the ratio of the CO2 emissions (% of total fuel combustion) of Bangladesh in 2006 to that in 2008?
Keep it short and to the point. 1.12. What is the ratio of the CO2 emissions (% of total fuel combustion) in Greece in 2006 to that in 2008?
Make the answer very short. 1.15. What is the ratio of the CO2 emissions (% of total fuel combustion) of Ukraine in 2006 to that in 2008?
Your answer should be compact. 1.02. What is the ratio of the CO2 emissions (% of total fuel combustion) of East Asia (developing only) in 2006 to that in 2009?
Your response must be concise. 1.18. What is the ratio of the CO2 emissions (% of total fuel combustion) of Bangladesh in 2006 to that in 2009?
Make the answer very short. 1.22. What is the ratio of the CO2 emissions (% of total fuel combustion) in Greece in 2006 to that in 2009?
Ensure brevity in your answer.  1.39. What is the ratio of the CO2 emissions (% of total fuel combustion) of Ukraine in 2006 to that in 2009?
Give a very brief answer. 0.9. What is the ratio of the CO2 emissions (% of total fuel combustion) of East Asia (developing only) in 2006 to that in 2010?
Your answer should be compact. 1.19. What is the ratio of the CO2 emissions (% of total fuel combustion) of Bangladesh in 2006 to that in 2010?
Your answer should be very brief. 1.22. What is the ratio of the CO2 emissions (% of total fuel combustion) of Greece in 2006 to that in 2010?
Provide a succinct answer. 1.52. What is the ratio of the CO2 emissions (% of total fuel combustion) in Ukraine in 2006 to that in 2010?
Provide a short and direct response. 0.92. What is the ratio of the CO2 emissions (% of total fuel combustion) of East Asia (developing only) in 2007 to that in 2008?
Your answer should be very brief. 1.08. What is the ratio of the CO2 emissions (% of total fuel combustion) of Bangladesh in 2007 to that in 2008?
Make the answer very short. 1.06. What is the ratio of the CO2 emissions (% of total fuel combustion) of Ukraine in 2007 to that in 2008?
Ensure brevity in your answer.  1.02. What is the ratio of the CO2 emissions (% of total fuel combustion) of East Asia (developing only) in 2007 to that in 2009?
Give a very brief answer. 1.08. What is the ratio of the CO2 emissions (% of total fuel combustion) of Bangladesh in 2007 to that in 2009?
Your answer should be compact. 1.15. What is the ratio of the CO2 emissions (% of total fuel combustion) in Greece in 2007 to that in 2009?
Provide a short and direct response. 1.2. What is the ratio of the CO2 emissions (% of total fuel combustion) of Ukraine in 2007 to that in 2009?
Keep it short and to the point. 0.9. What is the ratio of the CO2 emissions (% of total fuel combustion) of East Asia (developing only) in 2007 to that in 2010?
Provide a succinct answer. 1.1. What is the ratio of the CO2 emissions (% of total fuel combustion) of Bangladesh in 2007 to that in 2010?
Keep it short and to the point. 1.16. What is the ratio of the CO2 emissions (% of total fuel combustion) in Greece in 2007 to that in 2010?
Ensure brevity in your answer.  1.31. What is the ratio of the CO2 emissions (% of total fuel combustion) of Ukraine in 2007 to that in 2010?
Provide a succinct answer. 0.92. What is the ratio of the CO2 emissions (% of total fuel combustion) in Bangladesh in 2008 to that in 2009?
Keep it short and to the point. 1.09. What is the ratio of the CO2 emissions (% of total fuel combustion) in Greece in 2008 to that in 2009?
Provide a succinct answer. 1.21. What is the ratio of the CO2 emissions (% of total fuel combustion) in Ukraine in 2008 to that in 2009?
Offer a very short reply. 0.88. What is the ratio of the CO2 emissions (% of total fuel combustion) in East Asia (developing only) in 2008 to that in 2010?
Your answer should be compact. 1.01. What is the ratio of the CO2 emissions (% of total fuel combustion) in Bangladesh in 2008 to that in 2010?
Keep it short and to the point. 1.1. What is the ratio of the CO2 emissions (% of total fuel combustion) in Greece in 2008 to that in 2010?
Keep it short and to the point. 1.32. What is the ratio of the CO2 emissions (% of total fuel combustion) in Ukraine in 2008 to that in 2010?
Keep it short and to the point. 0.9. What is the ratio of the CO2 emissions (% of total fuel combustion) in East Asia (developing only) in 2009 to that in 2010?
Offer a terse response. 1.01. What is the ratio of the CO2 emissions (% of total fuel combustion) of Bangladesh in 2009 to that in 2010?
Your answer should be compact. 1.01. What is the ratio of the CO2 emissions (% of total fuel combustion) of Greece in 2009 to that in 2010?
Offer a terse response. 1.09. What is the ratio of the CO2 emissions (% of total fuel combustion) of Ukraine in 2009 to that in 2010?
Provide a short and direct response. 1.02. What is the difference between the highest and the second highest CO2 emissions (% of total fuel combustion) in East Asia (developing only)?
Give a very brief answer. 0.09. What is the difference between the highest and the second highest CO2 emissions (% of total fuel combustion) in Bangladesh?
Offer a very short reply. 0.37. What is the difference between the highest and the second highest CO2 emissions (% of total fuel combustion) of Greece?
Keep it short and to the point. 0.18. What is the difference between the highest and the second highest CO2 emissions (% of total fuel combustion) of Ukraine?
Provide a succinct answer. 0.95. What is the difference between the highest and the lowest CO2 emissions (% of total fuel combustion) in East Asia (developing only)?
Keep it short and to the point. 0.59. What is the difference between the highest and the lowest CO2 emissions (% of total fuel combustion) in Bangladesh?
Your response must be concise. 1.69. What is the difference between the highest and the lowest CO2 emissions (% of total fuel combustion) of Greece?
Provide a short and direct response. 1.02. What is the difference between the highest and the lowest CO2 emissions (% of total fuel combustion) in Ukraine?
Offer a terse response. 1.14. 